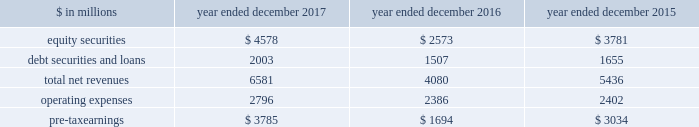The goldman sachs group , inc .
And subsidiaries management 2019s discussion and analysis investing & lending investing & lending includes our investing activities and the origination of loans , including our relationship lending activities , to provide financing to clients .
These investments and loans are typically longer-term in nature .
We make investments , some of which are consolidated , including through our merchant banking business and our special situations group , in debt securities and loans , public and private equity securities , infrastructure and real estate entities .
Some of these investments are made indirectly through funds that we manage .
We also make unsecured and secured loans to retail clients through our digital platforms , marcus and goldman sachs private bank select ( gs select ) , respectively .
The table below presents the operating results of our investing & lending segment. .
Operating environment .
During 2017 , generally higher global equity prices and tighter credit spreads contributed to a favorable environment for our equity and debt investments .
Results also reflected net gains from company- specific events , including sales , and corporate performance .
This environment contrasts with 2016 , where , in the first quarter of 2016 , market conditions were difficult and corporate performance , particularly in the energy sector , was impacted by a challenging macroeconomic environment .
However , market conditions improved during the rest of 2016 as macroeconomic concerns moderated .
If macroeconomic concerns negatively affect company-specific events or corporate performance , or if global equity markets decline or credit spreads widen , net revenues in investing & lending would likely be negatively impacted .
2017 versus 2016 .
Net revenues in investing & lending were $ 6.58 billion for 2017 , 61% ( 61 % ) higher than 2016 .
Net revenues in equity securities were $ 4.58 billion , including $ 3.82 billion of net gains from private equities and $ 762 million in net gains from public equities .
Net revenues in equity securities were 78% ( 78 % ) higher than 2016 , primarily reflecting a significant increase in net gains from private equities , which were positively impacted by company- specific events and corporate performance .
In addition , net gains from public equities were significantly higher , as global equity prices increased during the year .
Of the $ 4.58 billion of net revenues in equity securities , approximately 60% ( 60 % ) was driven by net gains from company-specific events , such as sales , and public equities .
Net revenues in debt securities and loans were $ 2.00 billion , 33% ( 33 % ) higher than 2016 , reflecting significantly higher net interest income ( 2017 included approximately $ 1.80 billion of net interest income ) .
Net revenues in debt securities and loans for 2017 also included an impairment of approximately $ 130 million on a secured operating expenses were $ 2.80 billion for 2017 , 17% ( 17 % ) higher than 2016 , due to increased compensation and benefits expenses , reflecting higher net revenues , increased expenses related to consolidated investments , and increased expenses related to marcus .
Pre-tax earnings were $ 3.79 billion in 2017 compared with $ 1.69 billion in 2016 .
2016 versus 2015 .
Net revenues in investing & lending were $ 4.08 billion for 2016 , 25% ( 25 % ) lower than 2015 .
Net revenues in equity securities were $ 2.57 billion , including $ 2.17 billion of net gains from private equities and $ 402 million in net gains from public equities .
Net revenues in equity securities were 32% ( 32 % ) lower than 2015 , primarily reflecting a significant decrease in net gains from private equities , driven by company-specific events and corporate performance .
Net revenues in debt securities and loans were $ 1.51 billion , 9% ( 9 % ) lower than 2015 , reflecting significantly lower net revenues related to relationship lending activities , due to the impact of changes in credit spreads on economic hedges .
Losses related to these hedges were $ 596 million in 2016 , compared with gains of $ 329 million in 2015 .
This decrease was partially offset by higher net gains from investments in debt instruments and higher net interest income .
See note 9 to the consolidated financial statements for further information about economic hedges related to our relationship lending activities .
Operating expenses were $ 2.39 billion for 2016 , essentially unchanged compared with 2015 .
Pre-tax earnings were $ 1.69 billion in 2016 , 44% ( 44 % ) lower than 2015 .
Goldman sachs 2017 form 10-k 61 .
Net revenues in equity securities were what in billions for 2017 when including net gains from private equities? 
Computations: (4.58 + 3.82)
Answer: 8.4. The goldman sachs group , inc .
And subsidiaries management 2019s discussion and analysis investing & lending investing & lending includes our investing activities and the origination of loans , including our relationship lending activities , to provide financing to clients .
These investments and loans are typically longer-term in nature .
We make investments , some of which are consolidated , including through our merchant banking business and our special situations group , in debt securities and loans , public and private equity securities , infrastructure and real estate entities .
Some of these investments are made indirectly through funds that we manage .
We also make unsecured and secured loans to retail clients through our digital platforms , marcus and goldman sachs private bank select ( gs select ) , respectively .
The table below presents the operating results of our investing & lending segment. .
Operating environment .
During 2017 , generally higher global equity prices and tighter credit spreads contributed to a favorable environment for our equity and debt investments .
Results also reflected net gains from company- specific events , including sales , and corporate performance .
This environment contrasts with 2016 , where , in the first quarter of 2016 , market conditions were difficult and corporate performance , particularly in the energy sector , was impacted by a challenging macroeconomic environment .
However , market conditions improved during the rest of 2016 as macroeconomic concerns moderated .
If macroeconomic concerns negatively affect company-specific events or corporate performance , or if global equity markets decline or credit spreads widen , net revenues in investing & lending would likely be negatively impacted .
2017 versus 2016 .
Net revenues in investing & lending were $ 6.58 billion for 2017 , 61% ( 61 % ) higher than 2016 .
Net revenues in equity securities were $ 4.58 billion , including $ 3.82 billion of net gains from private equities and $ 762 million in net gains from public equities .
Net revenues in equity securities were 78% ( 78 % ) higher than 2016 , primarily reflecting a significant increase in net gains from private equities , which were positively impacted by company- specific events and corporate performance .
In addition , net gains from public equities were significantly higher , as global equity prices increased during the year .
Of the $ 4.58 billion of net revenues in equity securities , approximately 60% ( 60 % ) was driven by net gains from company-specific events , such as sales , and public equities .
Net revenues in debt securities and loans were $ 2.00 billion , 33% ( 33 % ) higher than 2016 , reflecting significantly higher net interest income ( 2017 included approximately $ 1.80 billion of net interest income ) .
Net revenues in debt securities and loans for 2017 also included an impairment of approximately $ 130 million on a secured operating expenses were $ 2.80 billion for 2017 , 17% ( 17 % ) higher than 2016 , due to increased compensation and benefits expenses , reflecting higher net revenues , increased expenses related to consolidated investments , and increased expenses related to marcus .
Pre-tax earnings were $ 3.79 billion in 2017 compared with $ 1.69 billion in 2016 .
2016 versus 2015 .
Net revenues in investing & lending were $ 4.08 billion for 2016 , 25% ( 25 % ) lower than 2015 .
Net revenues in equity securities were $ 2.57 billion , including $ 2.17 billion of net gains from private equities and $ 402 million in net gains from public equities .
Net revenues in equity securities were 32% ( 32 % ) lower than 2015 , primarily reflecting a significant decrease in net gains from private equities , driven by company-specific events and corporate performance .
Net revenues in debt securities and loans were $ 1.51 billion , 9% ( 9 % ) lower than 2015 , reflecting significantly lower net revenues related to relationship lending activities , due to the impact of changes in credit spreads on economic hedges .
Losses related to these hedges were $ 596 million in 2016 , compared with gains of $ 329 million in 2015 .
This decrease was partially offset by higher net gains from investments in debt instruments and higher net interest income .
See note 9 to the consolidated financial statements for further information about economic hedges related to our relationship lending activities .
Operating expenses were $ 2.39 billion for 2016 , essentially unchanged compared with 2015 .
Pre-tax earnings were $ 1.69 billion in 2016 , 44% ( 44 % ) lower than 2015 .
Goldman sachs 2017 form 10-k 61 .
In millions for 2017 , 2016 , and 2015 , what was the minimum amount of equity securities? 
Computations: table_min(equity securities, none)
Answer: 2573.0. The goldman sachs group , inc .
And subsidiaries management 2019s discussion and analysis investing & lending investing & lending includes our investing activities and the origination of loans , including our relationship lending activities , to provide financing to clients .
These investments and loans are typically longer-term in nature .
We make investments , some of which are consolidated , including through our merchant banking business and our special situations group , in debt securities and loans , public and private equity securities , infrastructure and real estate entities .
Some of these investments are made indirectly through funds that we manage .
We also make unsecured and secured loans to retail clients through our digital platforms , marcus and goldman sachs private bank select ( gs select ) , respectively .
The table below presents the operating results of our investing & lending segment. .
Operating environment .
During 2017 , generally higher global equity prices and tighter credit spreads contributed to a favorable environment for our equity and debt investments .
Results also reflected net gains from company- specific events , including sales , and corporate performance .
This environment contrasts with 2016 , where , in the first quarter of 2016 , market conditions were difficult and corporate performance , particularly in the energy sector , was impacted by a challenging macroeconomic environment .
However , market conditions improved during the rest of 2016 as macroeconomic concerns moderated .
If macroeconomic concerns negatively affect company-specific events or corporate performance , or if global equity markets decline or credit spreads widen , net revenues in investing & lending would likely be negatively impacted .
2017 versus 2016 .
Net revenues in investing & lending were $ 6.58 billion for 2017 , 61% ( 61 % ) higher than 2016 .
Net revenues in equity securities were $ 4.58 billion , including $ 3.82 billion of net gains from private equities and $ 762 million in net gains from public equities .
Net revenues in equity securities were 78% ( 78 % ) higher than 2016 , primarily reflecting a significant increase in net gains from private equities , which were positively impacted by company- specific events and corporate performance .
In addition , net gains from public equities were significantly higher , as global equity prices increased during the year .
Of the $ 4.58 billion of net revenues in equity securities , approximately 60% ( 60 % ) was driven by net gains from company-specific events , such as sales , and public equities .
Net revenues in debt securities and loans were $ 2.00 billion , 33% ( 33 % ) higher than 2016 , reflecting significantly higher net interest income ( 2017 included approximately $ 1.80 billion of net interest income ) .
Net revenues in debt securities and loans for 2017 also included an impairment of approximately $ 130 million on a secured operating expenses were $ 2.80 billion for 2017 , 17% ( 17 % ) higher than 2016 , due to increased compensation and benefits expenses , reflecting higher net revenues , increased expenses related to consolidated investments , and increased expenses related to marcus .
Pre-tax earnings were $ 3.79 billion in 2017 compared with $ 1.69 billion in 2016 .
2016 versus 2015 .
Net revenues in investing & lending were $ 4.08 billion for 2016 , 25% ( 25 % ) lower than 2015 .
Net revenues in equity securities were $ 2.57 billion , including $ 2.17 billion of net gains from private equities and $ 402 million in net gains from public equities .
Net revenues in equity securities were 32% ( 32 % ) lower than 2015 , primarily reflecting a significant decrease in net gains from private equities , driven by company-specific events and corporate performance .
Net revenues in debt securities and loans were $ 1.51 billion , 9% ( 9 % ) lower than 2015 , reflecting significantly lower net revenues related to relationship lending activities , due to the impact of changes in credit spreads on economic hedges .
Losses related to these hedges were $ 596 million in 2016 , compared with gains of $ 329 million in 2015 .
This decrease was partially offset by higher net gains from investments in debt instruments and higher net interest income .
See note 9 to the consolidated financial statements for further information about economic hedges related to our relationship lending activities .
Operating expenses were $ 2.39 billion for 2016 , essentially unchanged compared with 2015 .
Pre-tax earnings were $ 1.69 billion in 2016 , 44% ( 44 % ) lower than 2015 .
Goldman sachs 2017 form 10-k 61 .
What percentage of total net revenue in the investing & lending segment during 2017 was comprised of equity securities? 
Computations: (4578 / 6581)
Answer: 0.69564. The goldman sachs group , inc .
And subsidiaries management 2019s discussion and analysis investing & lending investing & lending includes our investing activities and the origination of loans , including our relationship lending activities , to provide financing to clients .
These investments and loans are typically longer-term in nature .
We make investments , some of which are consolidated , including through our merchant banking business and our special situations group , in debt securities and loans , public and private equity securities , infrastructure and real estate entities .
Some of these investments are made indirectly through funds that we manage .
We also make unsecured and secured loans to retail clients through our digital platforms , marcus and goldman sachs private bank select ( gs select ) , respectively .
The table below presents the operating results of our investing & lending segment. .
Operating environment .
During 2017 , generally higher global equity prices and tighter credit spreads contributed to a favorable environment for our equity and debt investments .
Results also reflected net gains from company- specific events , including sales , and corporate performance .
This environment contrasts with 2016 , where , in the first quarter of 2016 , market conditions were difficult and corporate performance , particularly in the energy sector , was impacted by a challenging macroeconomic environment .
However , market conditions improved during the rest of 2016 as macroeconomic concerns moderated .
If macroeconomic concerns negatively affect company-specific events or corporate performance , or if global equity markets decline or credit spreads widen , net revenues in investing & lending would likely be negatively impacted .
2017 versus 2016 .
Net revenues in investing & lending were $ 6.58 billion for 2017 , 61% ( 61 % ) higher than 2016 .
Net revenues in equity securities were $ 4.58 billion , including $ 3.82 billion of net gains from private equities and $ 762 million in net gains from public equities .
Net revenues in equity securities were 78% ( 78 % ) higher than 2016 , primarily reflecting a significant increase in net gains from private equities , which were positively impacted by company- specific events and corporate performance .
In addition , net gains from public equities were significantly higher , as global equity prices increased during the year .
Of the $ 4.58 billion of net revenues in equity securities , approximately 60% ( 60 % ) was driven by net gains from company-specific events , such as sales , and public equities .
Net revenues in debt securities and loans were $ 2.00 billion , 33% ( 33 % ) higher than 2016 , reflecting significantly higher net interest income ( 2017 included approximately $ 1.80 billion of net interest income ) .
Net revenues in debt securities and loans for 2017 also included an impairment of approximately $ 130 million on a secured operating expenses were $ 2.80 billion for 2017 , 17% ( 17 % ) higher than 2016 , due to increased compensation and benefits expenses , reflecting higher net revenues , increased expenses related to consolidated investments , and increased expenses related to marcus .
Pre-tax earnings were $ 3.79 billion in 2017 compared with $ 1.69 billion in 2016 .
2016 versus 2015 .
Net revenues in investing & lending were $ 4.08 billion for 2016 , 25% ( 25 % ) lower than 2015 .
Net revenues in equity securities were $ 2.57 billion , including $ 2.17 billion of net gains from private equities and $ 402 million in net gains from public equities .
Net revenues in equity securities were 32% ( 32 % ) lower than 2015 , primarily reflecting a significant decrease in net gains from private equities , driven by company-specific events and corporate performance .
Net revenues in debt securities and loans were $ 1.51 billion , 9% ( 9 % ) lower than 2015 , reflecting significantly lower net revenues related to relationship lending activities , due to the impact of changes in credit spreads on economic hedges .
Losses related to these hedges were $ 596 million in 2016 , compared with gains of $ 329 million in 2015 .
This decrease was partially offset by higher net gains from investments in debt instruments and higher net interest income .
See note 9 to the consolidated financial statements for further information about economic hedges related to our relationship lending activities .
Operating expenses were $ 2.39 billion for 2016 , essentially unchanged compared with 2015 .
Pre-tax earnings were $ 1.69 billion in 2016 , 44% ( 44 % ) lower than 2015 .
Goldman sachs 2017 form 10-k 61 .
What percentage of total net revenue in the investing & lending segment during 2016 was comprised of equity securities? 
Computations: (2573 / 4080)
Answer: 0.63064. 